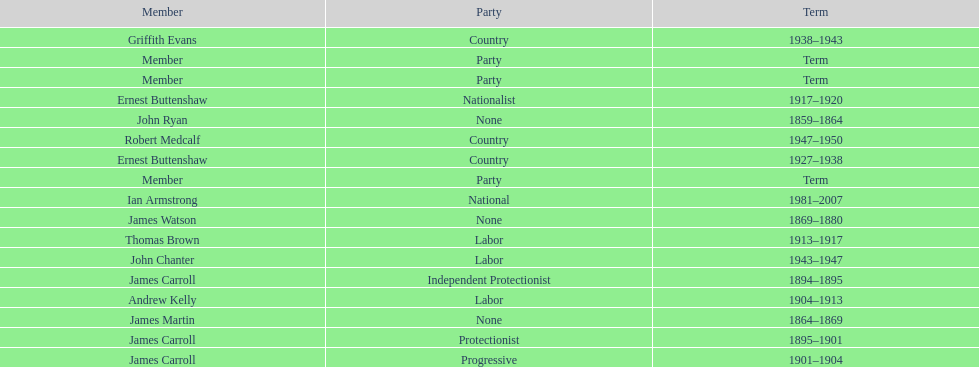How many years of service do the members of the second incarnation have combined? 26. 